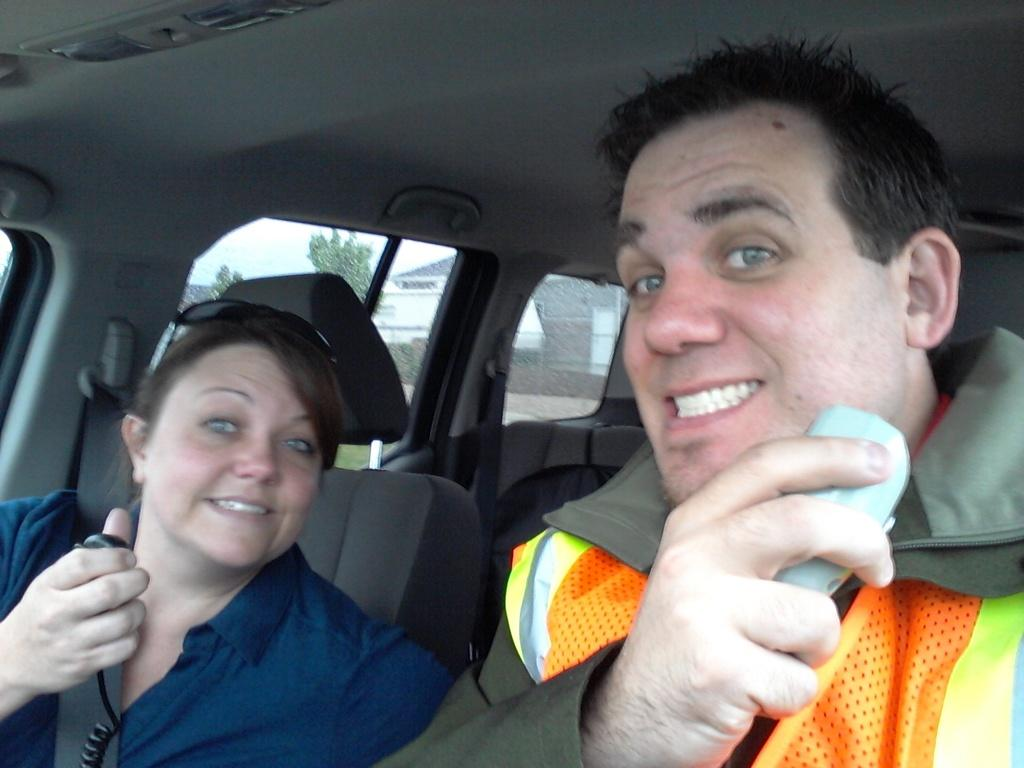How many people are in the image? There are two people in the image. Where are the two people located in the image? The two people are sitting inside a car. What can be seen outside the car in the image? There are trees visible outside the car. What is visible at the top of the image? The sky is visible in the image. Where is the cub playing in the image? There is no cub present in the image. What type of party is taking place in the image? There is no party present in the image. 